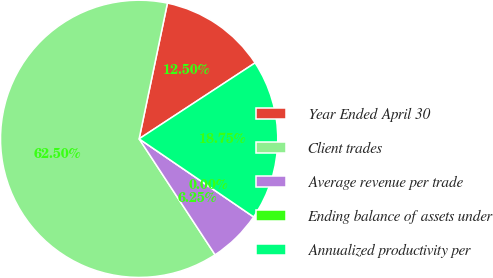Convert chart to OTSL. <chart><loc_0><loc_0><loc_500><loc_500><pie_chart><fcel>Year Ended April 30<fcel>Client trades<fcel>Average revenue per trade<fcel>Ending balance of assets under<fcel>Annualized productivity per<nl><fcel>12.5%<fcel>62.5%<fcel>6.25%<fcel>0.0%<fcel>18.75%<nl></chart> 